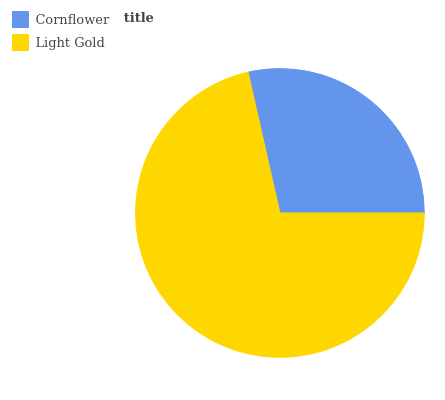Is Cornflower the minimum?
Answer yes or no. Yes. Is Light Gold the maximum?
Answer yes or no. Yes. Is Light Gold the minimum?
Answer yes or no. No. Is Light Gold greater than Cornflower?
Answer yes or no. Yes. Is Cornflower less than Light Gold?
Answer yes or no. Yes. Is Cornflower greater than Light Gold?
Answer yes or no. No. Is Light Gold less than Cornflower?
Answer yes or no. No. Is Light Gold the high median?
Answer yes or no. Yes. Is Cornflower the low median?
Answer yes or no. Yes. Is Cornflower the high median?
Answer yes or no. No. Is Light Gold the low median?
Answer yes or no. No. 